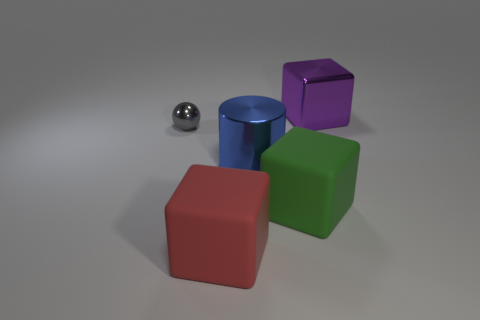Subtract all green blocks. How many blocks are left? 2 Add 1 large green matte blocks. How many objects exist? 6 Subtract all green cubes. How many cubes are left? 2 Subtract 2 blocks. How many blocks are left? 1 Subtract all cyan balls. How many green cubes are left? 1 Subtract all brown metallic balls. Subtract all red matte things. How many objects are left? 4 Add 4 big rubber objects. How many big rubber objects are left? 6 Add 1 metal cylinders. How many metal cylinders exist? 2 Subtract 0 blue balls. How many objects are left? 5 Subtract all spheres. How many objects are left? 4 